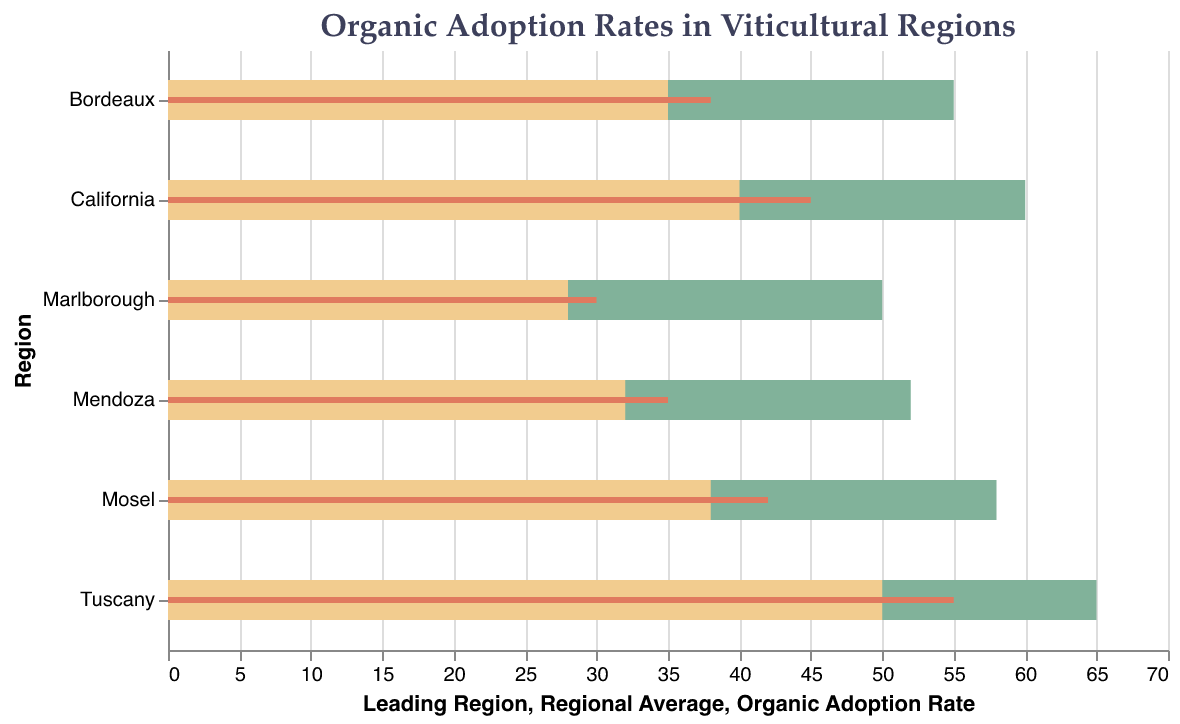How many regions are compared in the chart? The chart contains a bar for each region compared. To find the number of regions, we count the distinct bars present.
Answer: 6 What is the organic adoption rate in Tuscany? The bars representing organic adoption rates are shown with a specific color, and the rate is labeled by region. Examining the labels reveals that Tuscany's rate is 55%.
Answer: 55% Which region has the lowest organic adoption rate? By comparing the organic adoption rate bars, the smallest value appears to be from Marlborough, with a rate of 30%.
Answer: Marlborough How does the organic adoption rate in Bordeaux compare to its regional average? Bordeaux has an organic adoption rate indicated as 38%. The regional average for Bordeaux is shown as 35%. The adoption rate is 3% higher than the regional average.
Answer: 3% higher Which region has the highest leading region rate and what is it? The "Leading Region" rates are indicated with bars. The highest value among these is labeled for Tuscany at 65%.
Answer: Tuscany, 65% What is the approximate difference between the organic adoption rate and the leading region rate for Mosel? The organic adoption rate for Mosel is given as 42%, while its leading region rate is 58%. The difference is 16% (58% - 42%).
Answer: 16% Rank the regions in descending order based on their organic adoption rates. To rank the regions, list the regions along with their adoption rates in descending order: Tuscany (55%), California (45%), Mosel (42%), Bordeaux (38%), Mendoza (35%), Marlborough (30%).
Answer: Tuscany, California, Mosel, Bordeaux, Mendoza, Marlborough What is the average of the organic adoption rates across all regions? Sum up all the organic adoption rates: 45 + 55 + 38 + 30 + 42 + 35 = 245. Then divide by the number of regions, which is 6. So, 245/6 ≈ 40.83.
Answer: 40.83 Which region has an organic adoption rate closest to the regional average? Compare the organic adoption rates and regional averages for each region: California (45 with average of 40), Tuscany (55 with average of 50), Bordeaux (38 with average of 35), Marlborough (30 with average of 28), Mosel (42 with average of 38), and Mendoza (35 with average of 32). The closest match is Bordeaux, where the difference is only 3%.
Answer: Bordeaux 